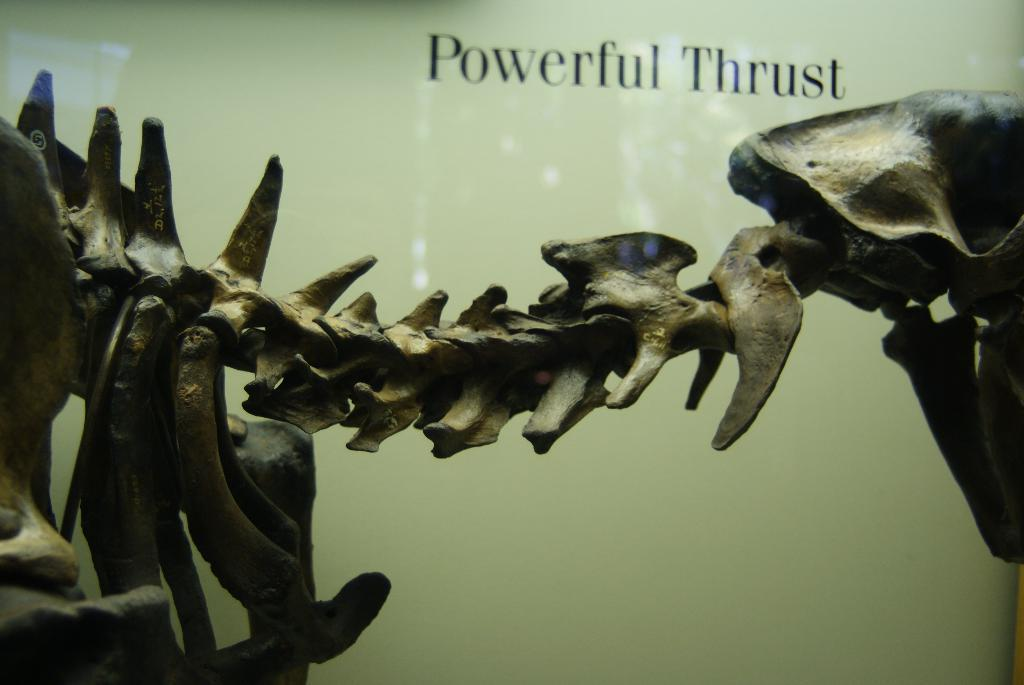What is the main subject of the image? There is a skeleton in the image. What else can be seen in the background of the image? There is text on a board in the background of the image. What object is located in the foreground of the image? There appears to be a mirror in the foreground of the image. How many horses are depicted in the image? There are no horses present in the image. What type of wound can be seen on the skeleton in the image? There is no wound visible on the skeleton in the image, as it is a complete skeleton. 